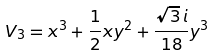<formula> <loc_0><loc_0><loc_500><loc_500>V _ { 3 } = x ^ { 3 } + \frac { 1 } { 2 } x y ^ { 2 } + \frac { \sqrt { 3 } \, i } { 1 8 } y ^ { 3 }</formula> 